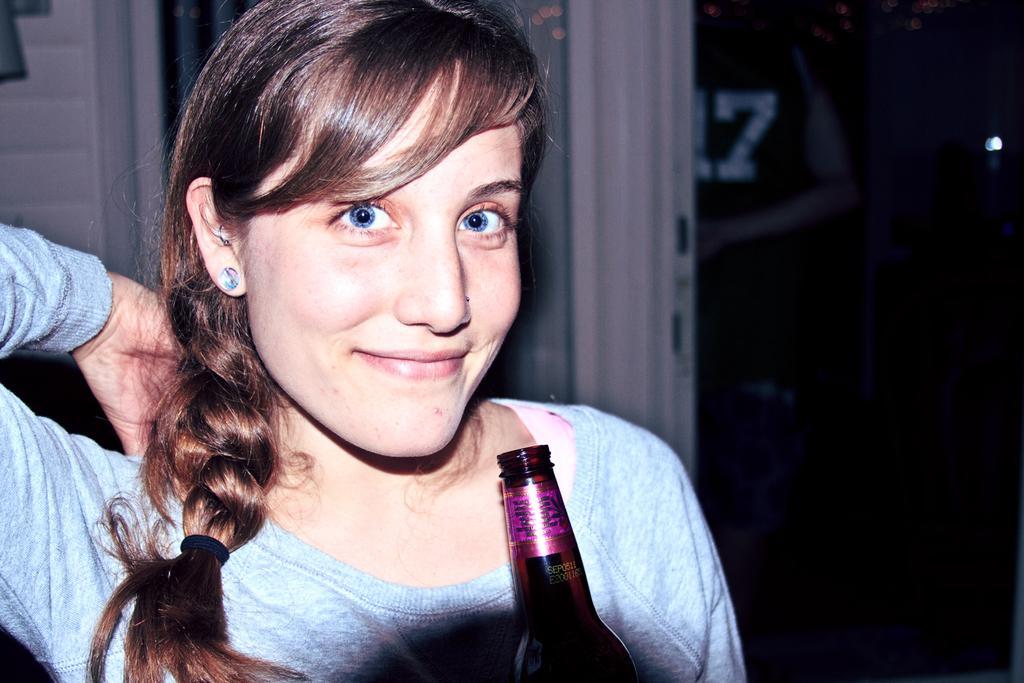How would you summarize this image in a sentence or two? Here we can see a woman with a bottle in her hand smiling 